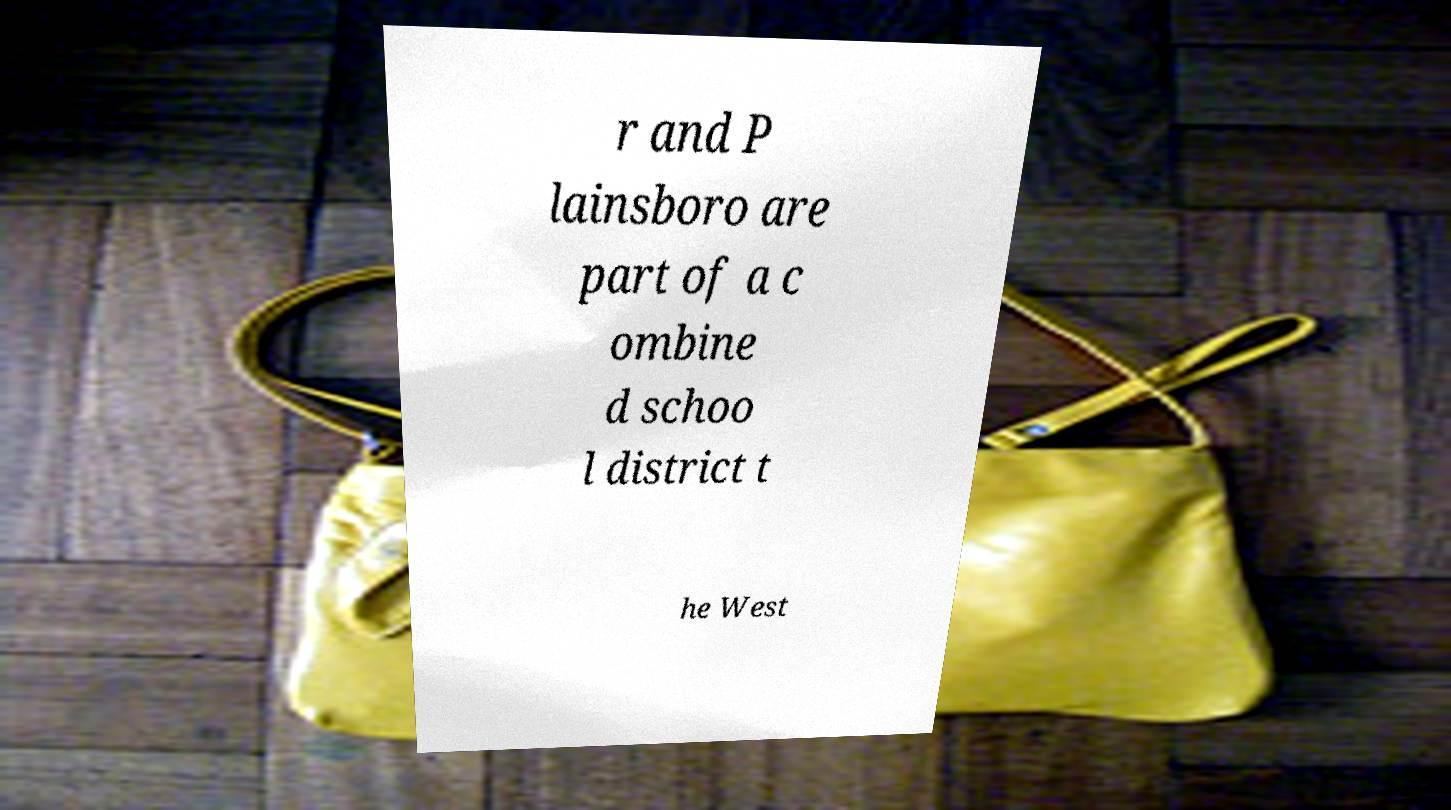Could you extract and type out the text from this image? r and P lainsboro are part of a c ombine d schoo l district t he West 